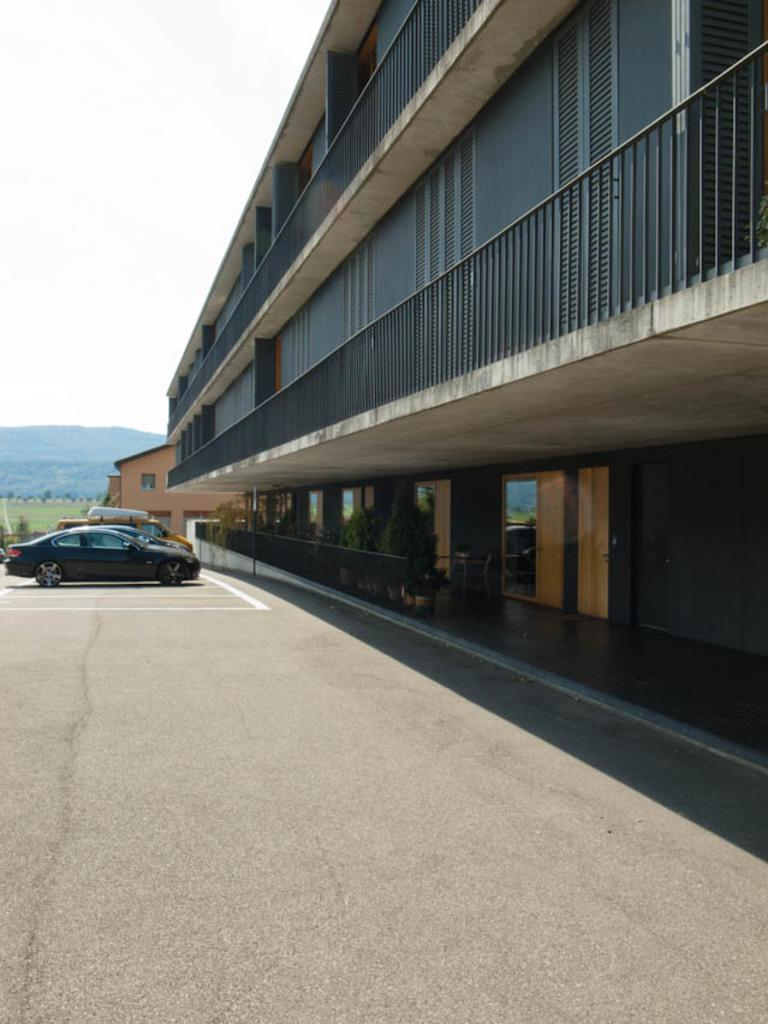What can be seen in the sky in the image? The sky is visible in the image, but no specific details about the sky can be determined from the provided facts. What type of structures are present in the image? There are buildings in the image. What mode of transportation can be seen in the image? Motor vehicles are present in the image. What type of pathway is visible in the image? There is a road in the image. What type of barrier is visible in the image? An iron grill is visible in the image. What type of natural elements are present in the image? Plants and trees are present in the image. What type of surface is visible in the image? The ground is visible in the image. How many circles are present in the image? There is no mention of circles in the provided facts, so it cannot be determined how many circles are present in the image. What is the boundary of the image? The boundary of the image refers to the edges of the photograph or digital file, not to any element within the image itself. 